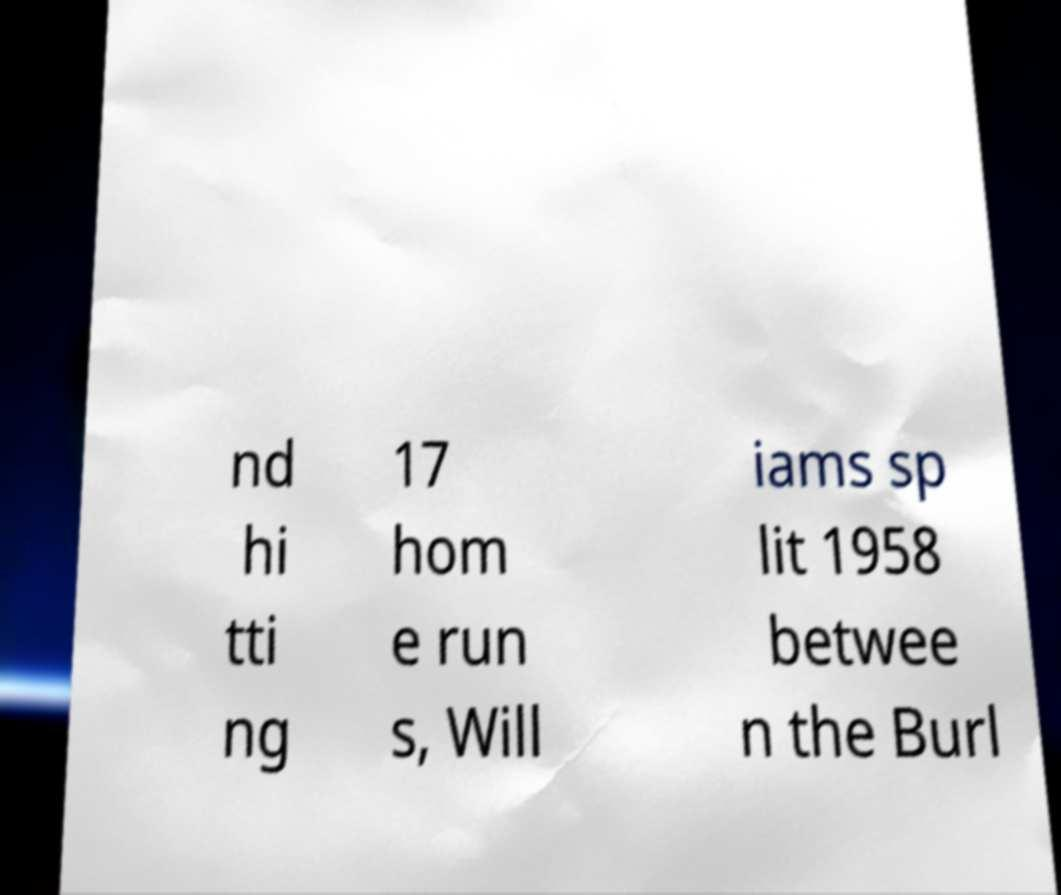Could you assist in decoding the text presented in this image and type it out clearly? nd hi tti ng 17 hom e run s, Will iams sp lit 1958 betwee n the Burl 